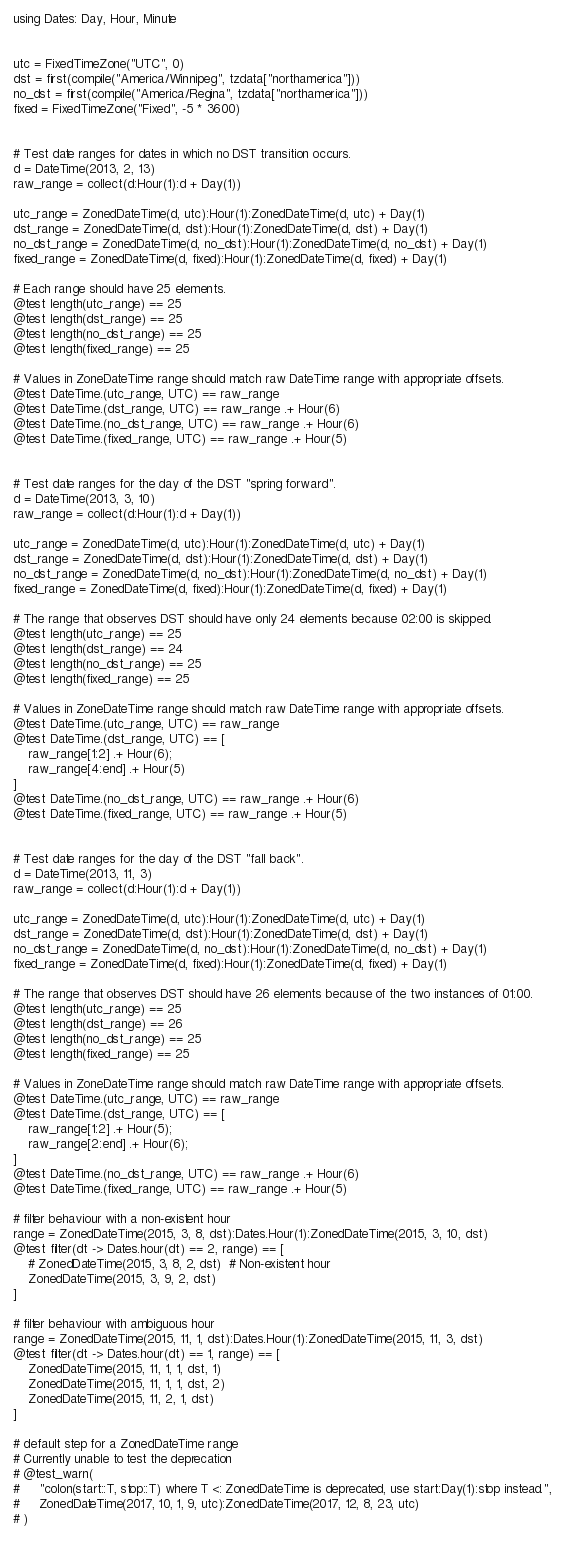Convert code to text. <code><loc_0><loc_0><loc_500><loc_500><_Julia_>using Dates: Day, Hour, Minute


utc = FixedTimeZone("UTC", 0)
dst = first(compile("America/Winnipeg", tzdata["northamerica"]))
no_dst = first(compile("America/Regina", tzdata["northamerica"]))
fixed = FixedTimeZone("Fixed", -5 * 3600)


# Test date ranges for dates in which no DST transition occurs.
d = DateTime(2013, 2, 13)
raw_range = collect(d:Hour(1):d + Day(1))

utc_range = ZonedDateTime(d, utc):Hour(1):ZonedDateTime(d, utc) + Day(1)
dst_range = ZonedDateTime(d, dst):Hour(1):ZonedDateTime(d, dst) + Day(1)
no_dst_range = ZonedDateTime(d, no_dst):Hour(1):ZonedDateTime(d, no_dst) + Day(1)
fixed_range = ZonedDateTime(d, fixed):Hour(1):ZonedDateTime(d, fixed) + Day(1)

# Each range should have 25 elements.
@test length(utc_range) == 25
@test length(dst_range) == 25
@test length(no_dst_range) == 25
@test length(fixed_range) == 25

# Values in ZoneDateTime range should match raw DateTime range with appropriate offsets.
@test DateTime.(utc_range, UTC) == raw_range
@test DateTime.(dst_range, UTC) == raw_range .+ Hour(6)
@test DateTime.(no_dst_range, UTC) == raw_range .+ Hour(6)
@test DateTime.(fixed_range, UTC) == raw_range .+ Hour(5)


# Test date ranges for the day of the DST "spring forward".
d = DateTime(2013, 3, 10)
raw_range = collect(d:Hour(1):d + Day(1))

utc_range = ZonedDateTime(d, utc):Hour(1):ZonedDateTime(d, utc) + Day(1)
dst_range = ZonedDateTime(d, dst):Hour(1):ZonedDateTime(d, dst) + Day(1)
no_dst_range = ZonedDateTime(d, no_dst):Hour(1):ZonedDateTime(d, no_dst) + Day(1)
fixed_range = ZonedDateTime(d, fixed):Hour(1):ZonedDateTime(d, fixed) + Day(1)

# The range that observes DST should have only 24 elements because 02:00 is skipped.
@test length(utc_range) == 25
@test length(dst_range) == 24
@test length(no_dst_range) == 25
@test length(fixed_range) == 25

# Values in ZoneDateTime range should match raw DateTime range with appropriate offsets.
@test DateTime.(utc_range, UTC) == raw_range
@test DateTime.(dst_range, UTC) == [
    raw_range[1:2] .+ Hour(6);
    raw_range[4:end] .+ Hour(5)
]
@test DateTime.(no_dst_range, UTC) == raw_range .+ Hour(6)
@test DateTime.(fixed_range, UTC) == raw_range .+ Hour(5)


# Test date ranges for the day of the DST "fall back".
d = DateTime(2013, 11, 3)
raw_range = collect(d:Hour(1):d + Day(1))

utc_range = ZonedDateTime(d, utc):Hour(1):ZonedDateTime(d, utc) + Day(1)
dst_range = ZonedDateTime(d, dst):Hour(1):ZonedDateTime(d, dst) + Day(1)
no_dst_range = ZonedDateTime(d, no_dst):Hour(1):ZonedDateTime(d, no_dst) + Day(1)
fixed_range = ZonedDateTime(d, fixed):Hour(1):ZonedDateTime(d, fixed) + Day(1)

# The range that observes DST should have 26 elements because of the two instances of 01:00.
@test length(utc_range) == 25
@test length(dst_range) == 26
@test length(no_dst_range) == 25
@test length(fixed_range) == 25

# Values in ZoneDateTime range should match raw DateTime range with appropriate offsets.
@test DateTime.(utc_range, UTC) == raw_range
@test DateTime.(dst_range, UTC) == [
    raw_range[1:2] .+ Hour(5);
    raw_range[2:end] .+ Hour(6);
]
@test DateTime.(no_dst_range, UTC) == raw_range .+ Hour(6)
@test DateTime.(fixed_range, UTC) == raw_range .+ Hour(5)

# filter behaviour with a non-existent hour
range = ZonedDateTime(2015, 3, 8, dst):Dates.Hour(1):ZonedDateTime(2015, 3, 10, dst)
@test filter(dt -> Dates.hour(dt) == 2, range) == [
    # ZonedDateTime(2015, 3, 8, 2, dst)  # Non-existent hour
    ZonedDateTime(2015, 3, 9, 2, dst)
]

# filter behaviour with ambiguous hour
range = ZonedDateTime(2015, 11, 1, dst):Dates.Hour(1):ZonedDateTime(2015, 11, 3, dst)
@test filter(dt -> Dates.hour(dt) == 1, range) == [
    ZonedDateTime(2015, 11, 1, 1, dst, 1)
    ZonedDateTime(2015, 11, 1, 1, dst, 2)
    ZonedDateTime(2015, 11, 2, 1, dst)
]

# default step for a ZonedDateTime range
# Currently unable to test the deprecation
# @test_warn(
#     "colon(start::T, stop::T) where T <: ZonedDateTime is deprecated, use start:Day(1):stop instead.",
#     ZonedDateTime(2017, 10, 1, 9, utc):ZonedDateTime(2017, 12, 8, 23, utc)
# )
</code> 